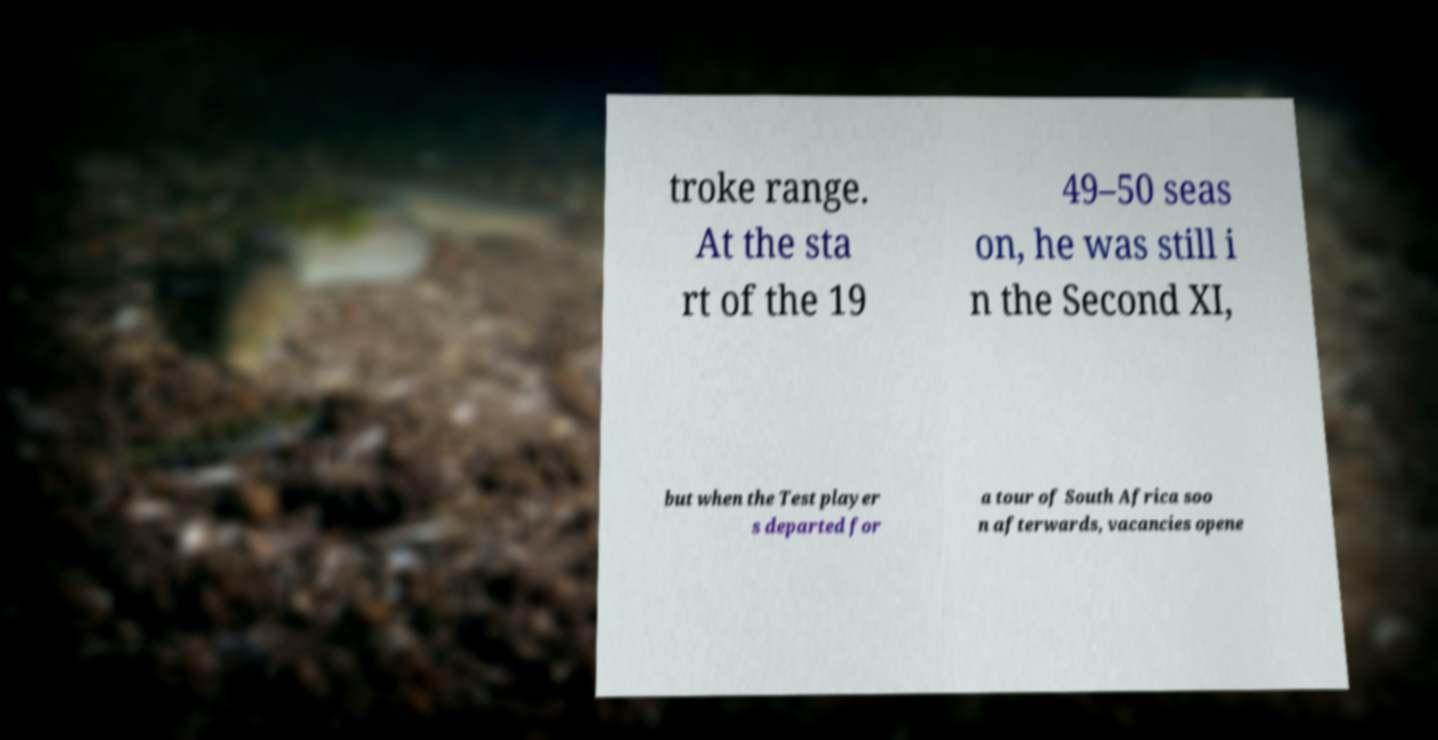I need the written content from this picture converted into text. Can you do that? troke range. At the sta rt of the 19 49–50 seas on, he was still i n the Second XI, but when the Test player s departed for a tour of South Africa soo n afterwards, vacancies opene 